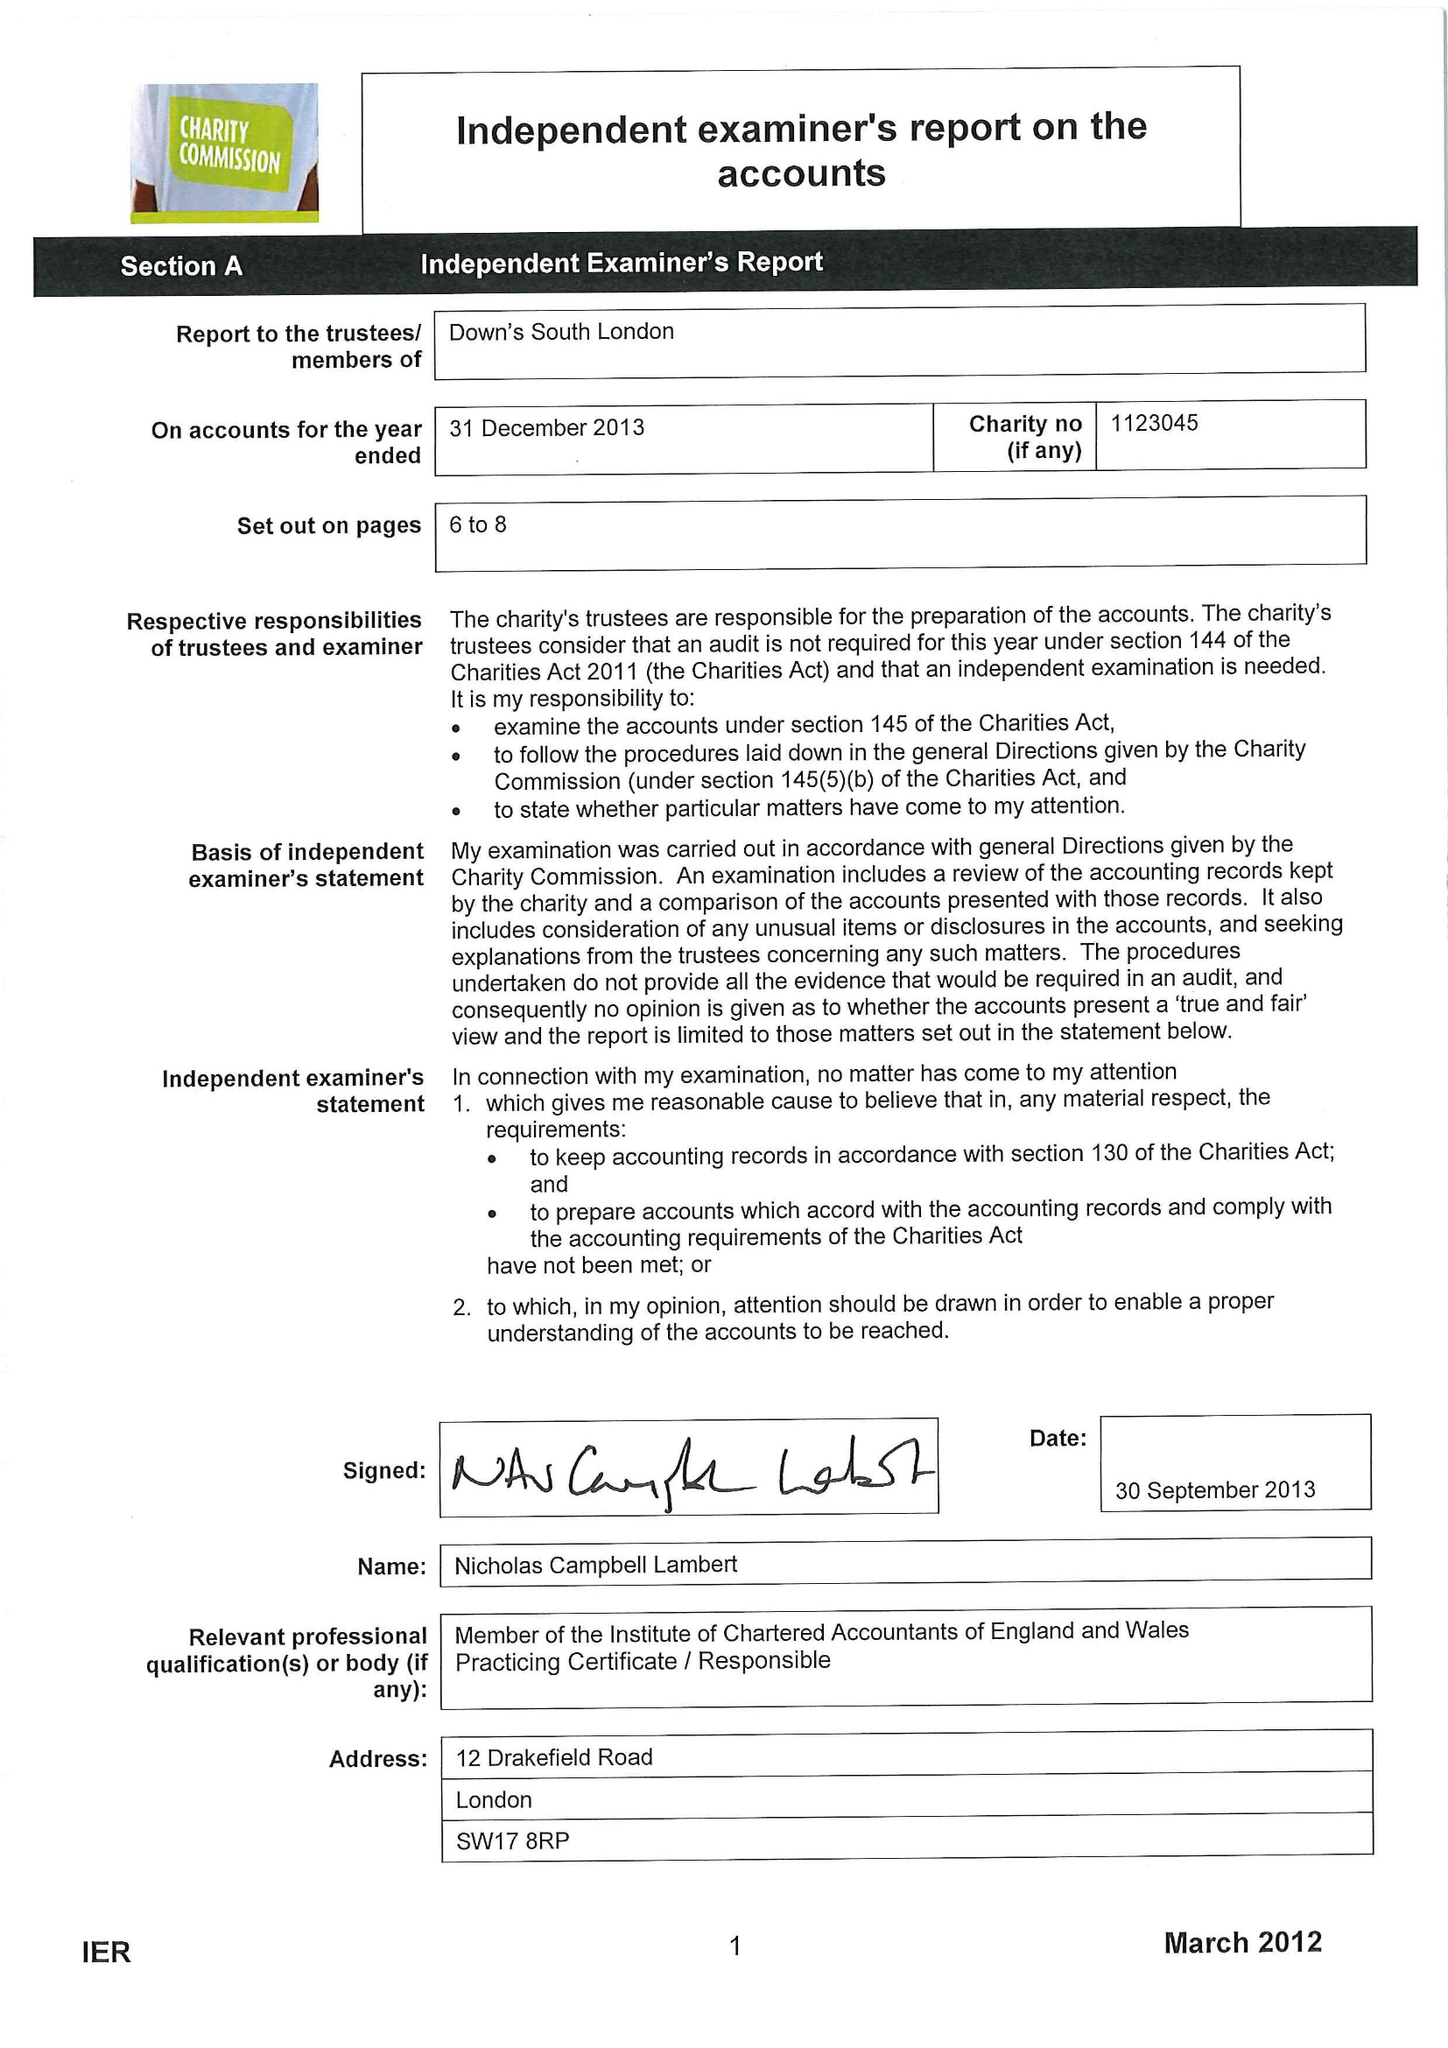What is the value for the address__street_line?
Answer the question using a single word or phrase. 59 LYNDHURST GROVE 